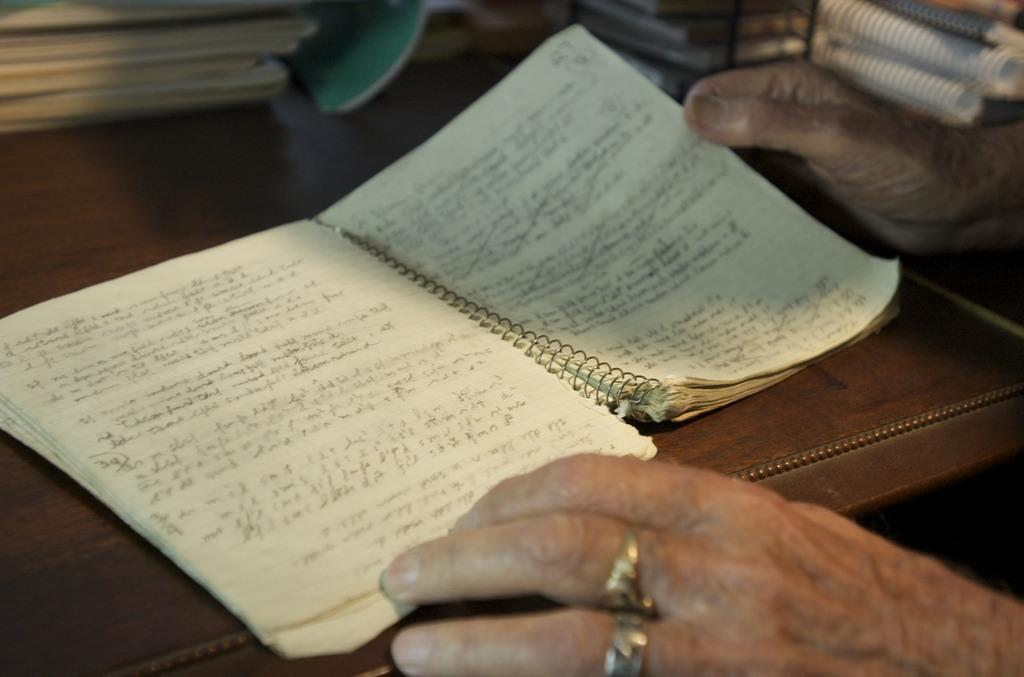What object is on the table in the image? There is a book on the table in the image. What can be seen on the book? There is writing on the book. Are there any other books visible in the image? Yes, there are additional books beside the table. What is the person in the image doing with a book? A person is holding a book in their hands. What type of dress is the person wearing while offering boats in the image? There is no person wearing a dress or offering boats in the image; it only features a book on a table and a person holding another book. 